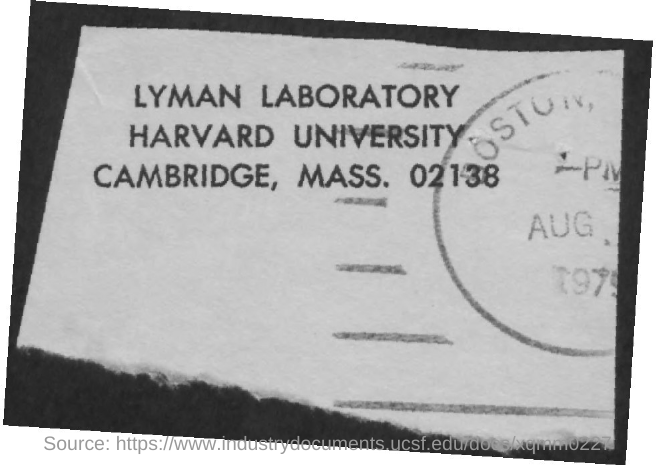Which University is mentioned in the postal address?
Offer a terse response. Harvard University. 